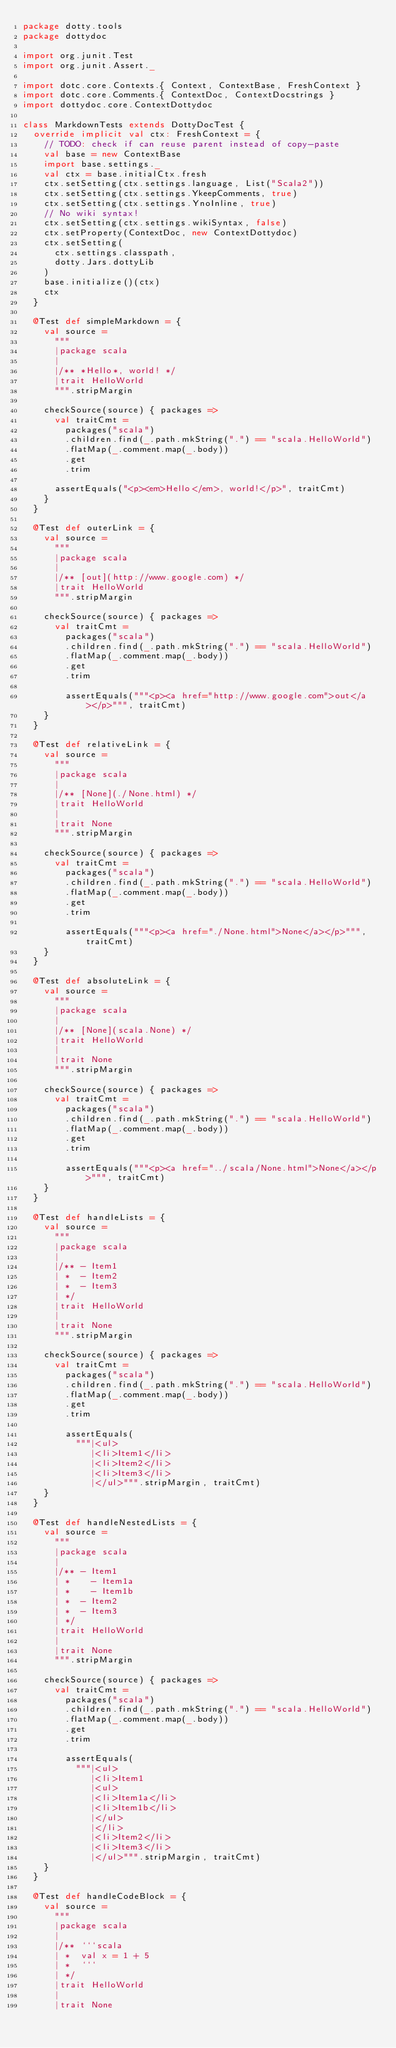Convert code to text. <code><loc_0><loc_0><loc_500><loc_500><_Scala_>package dotty.tools
package dottydoc

import org.junit.Test
import org.junit.Assert._

import dotc.core.Contexts.{ Context, ContextBase, FreshContext }
import dotc.core.Comments.{ ContextDoc, ContextDocstrings }
import dottydoc.core.ContextDottydoc

class MarkdownTests extends DottyDocTest {
  override implicit val ctx: FreshContext = {
    // TODO: check if can reuse parent instead of copy-paste
    val base = new ContextBase
    import base.settings._
    val ctx = base.initialCtx.fresh
    ctx.setSetting(ctx.settings.language, List("Scala2"))
    ctx.setSetting(ctx.settings.YkeepComments, true)
    ctx.setSetting(ctx.settings.YnoInline, true)
    // No wiki syntax!
    ctx.setSetting(ctx.settings.wikiSyntax, false)
    ctx.setProperty(ContextDoc, new ContextDottydoc)
    ctx.setSetting(
      ctx.settings.classpath,
      dotty.Jars.dottyLib
    )
    base.initialize()(ctx)
    ctx
  }

  @Test def simpleMarkdown = {
    val source =
      """
      |package scala
      |
      |/** *Hello*, world! */
      |trait HelloWorld
      """.stripMargin

    checkSource(source) { packages =>
      val traitCmt =
        packages("scala")
        .children.find(_.path.mkString(".") == "scala.HelloWorld")
        .flatMap(_.comment.map(_.body))
        .get
        .trim

      assertEquals("<p><em>Hello</em>, world!</p>", traitCmt)
    }
  }

  @Test def outerLink = {
    val source =
      """
      |package scala
      |
      |/** [out](http://www.google.com) */
      |trait HelloWorld
      """.stripMargin

    checkSource(source) { packages =>
      val traitCmt =
        packages("scala")
        .children.find(_.path.mkString(".") == "scala.HelloWorld")
        .flatMap(_.comment.map(_.body))
        .get
        .trim

        assertEquals("""<p><a href="http://www.google.com">out</a></p>""", traitCmt)
    }
  }

  @Test def relativeLink = {
    val source =
      """
      |package scala
      |
      |/** [None](./None.html) */
      |trait HelloWorld
      |
      |trait None
      """.stripMargin

    checkSource(source) { packages =>
      val traitCmt =
        packages("scala")
        .children.find(_.path.mkString(".") == "scala.HelloWorld")
        .flatMap(_.comment.map(_.body))
        .get
        .trim

        assertEquals("""<p><a href="./None.html">None</a></p>""", traitCmt)
    }
  }

  @Test def absoluteLink = {
    val source =
      """
      |package scala
      |
      |/** [None](scala.None) */
      |trait HelloWorld
      |
      |trait None
      """.stripMargin

    checkSource(source) { packages =>
      val traitCmt =
        packages("scala")
        .children.find(_.path.mkString(".") == "scala.HelloWorld")
        .flatMap(_.comment.map(_.body))
        .get
        .trim

        assertEquals("""<p><a href="../scala/None.html">None</a></p>""", traitCmt)
    }
  }

  @Test def handleLists = {
    val source =
      """
      |package scala
      |
      |/** - Item1
      | *  - Item2
      | *  - Item3
      | */
      |trait HelloWorld
      |
      |trait None
      """.stripMargin

    checkSource(source) { packages =>
      val traitCmt =
        packages("scala")
        .children.find(_.path.mkString(".") == "scala.HelloWorld")
        .flatMap(_.comment.map(_.body))
        .get
        .trim

        assertEquals(
          """|<ul>
             |<li>Item1</li>
             |<li>Item2</li>
             |<li>Item3</li>
             |</ul>""".stripMargin, traitCmt)
    }
  }

  @Test def handleNestedLists = {
    val source =
      """
      |package scala
      |
      |/** - Item1
      | *    - Item1a
      | *    - Item1b
      | *  - Item2
      | *  - Item3
      | */
      |trait HelloWorld
      |
      |trait None
      """.stripMargin

    checkSource(source) { packages =>
      val traitCmt =
        packages("scala")
        .children.find(_.path.mkString(".") == "scala.HelloWorld")
        .flatMap(_.comment.map(_.body))
        .get
        .trim

        assertEquals(
          """|<ul>
             |<li>Item1
             |<ul>
             |<li>Item1a</li>
             |<li>Item1b</li>
             |</ul>
             |</li>
             |<li>Item2</li>
             |<li>Item3</li>
             |</ul>""".stripMargin, traitCmt)
    }
  }

  @Test def handleCodeBlock = {
    val source =
      """
      |package scala
      |
      |/** ```scala
      | *  val x = 1 + 5
      | *  ```
      | */
      |trait HelloWorld
      |
      |trait None</code> 